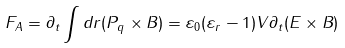Convert formula to latex. <formula><loc_0><loc_0><loc_500><loc_500>F _ { A } = \partial _ { t } \int d r ( P _ { q } \times B ) = \varepsilon _ { 0 } ( \varepsilon _ { r } - 1 ) V \partial _ { t } ( E \times B )</formula> 